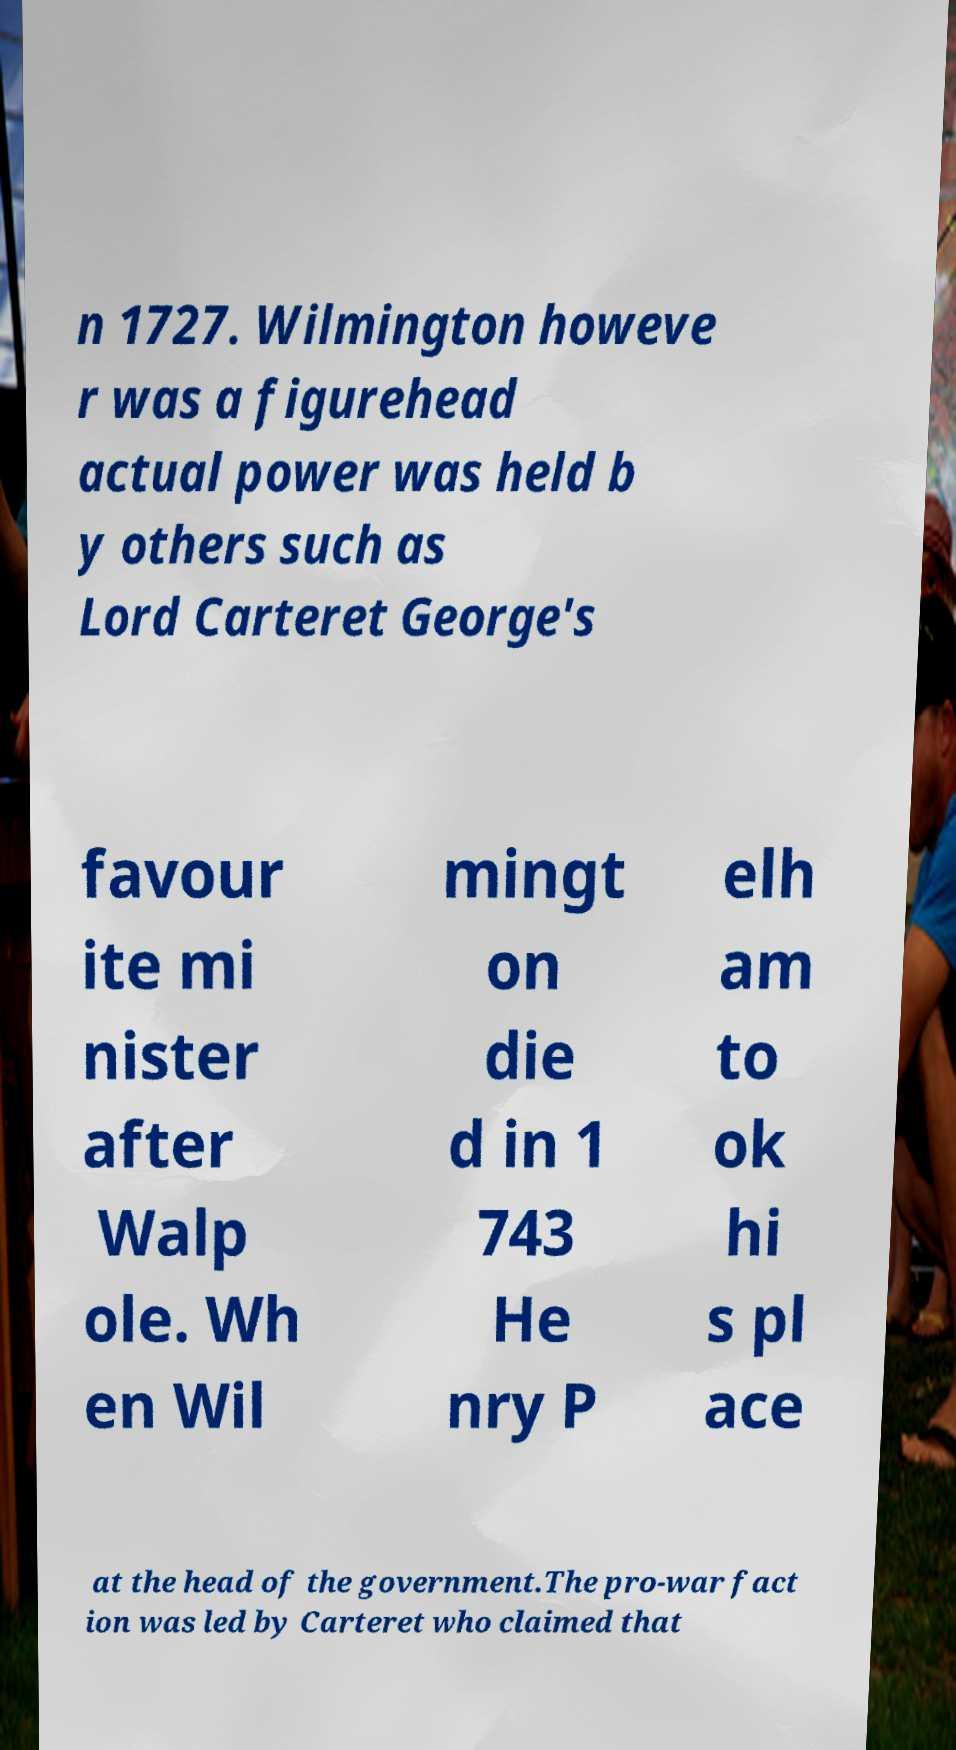Could you extract and type out the text from this image? n 1727. Wilmington howeve r was a figurehead actual power was held b y others such as Lord Carteret George's favour ite mi nister after Walp ole. Wh en Wil mingt on die d in 1 743 He nry P elh am to ok hi s pl ace at the head of the government.The pro-war fact ion was led by Carteret who claimed that 